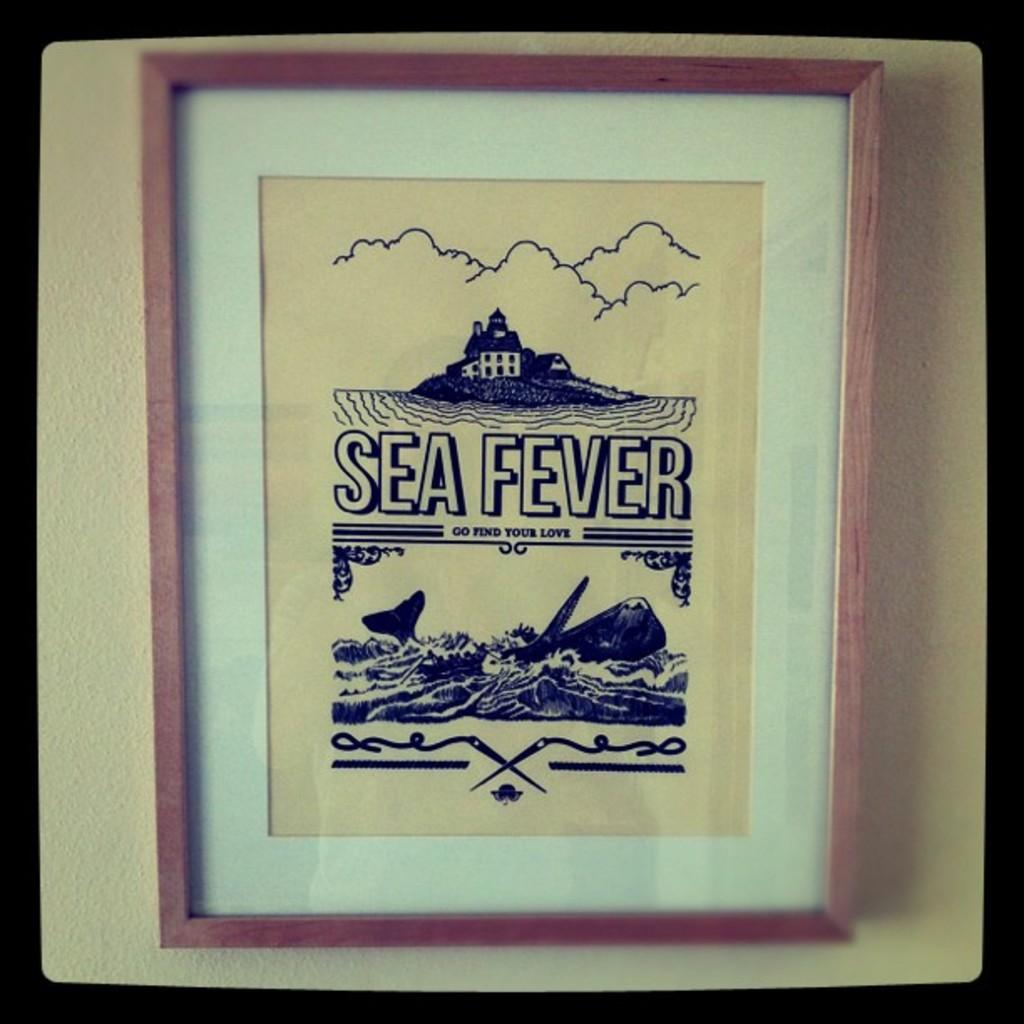<image>
Write a terse but informative summary of the picture. Picture framed on a wall that says Sea Fever. 